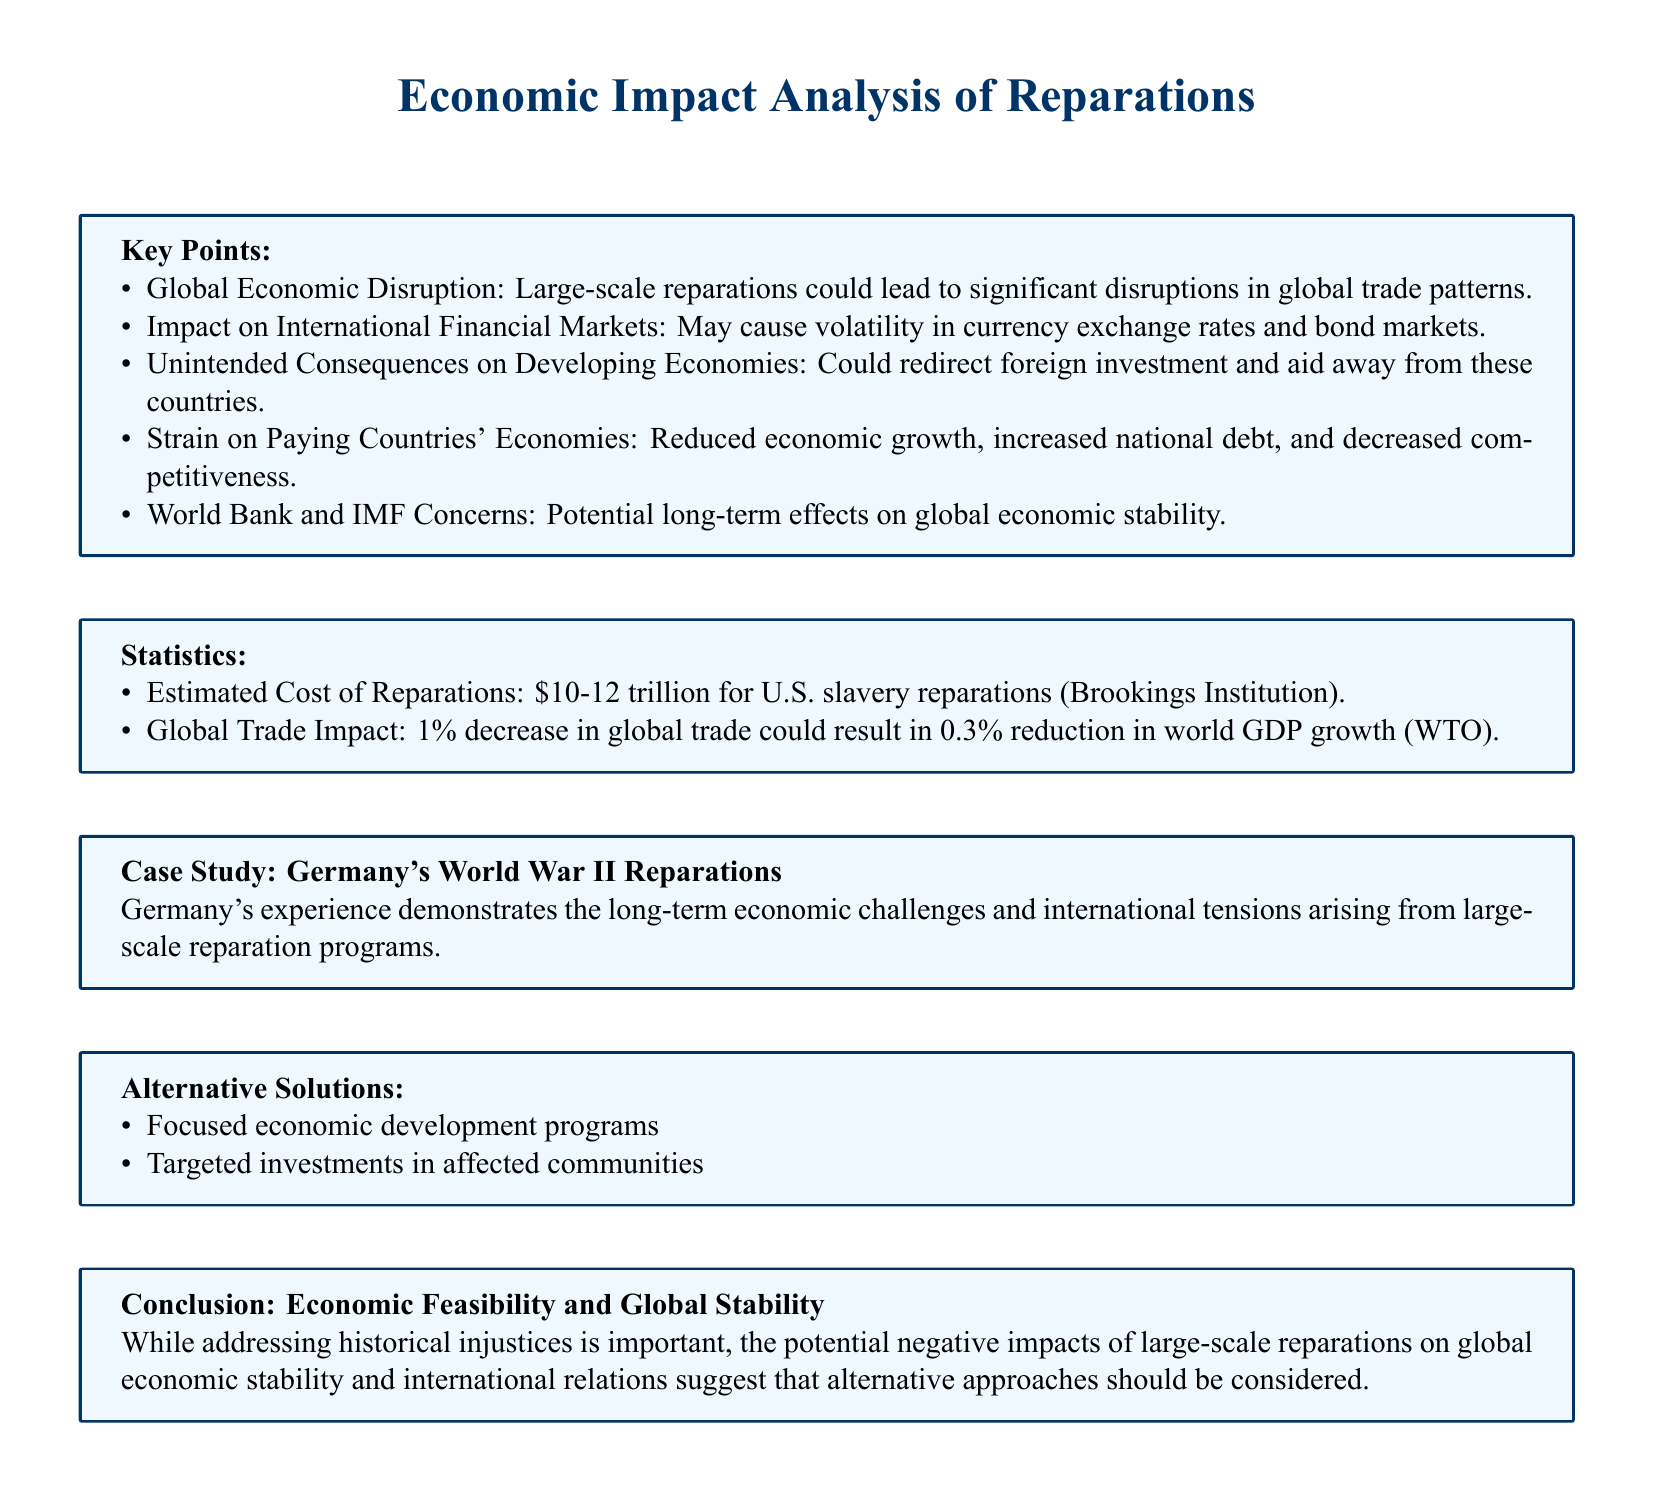What are the estimated costs of reparations? The document states an estimated cost for U.S. slavery reparations is between $10-12 trillion.
Answer: $10-12 trillion What is a potential consequence of large-scale reparations? It could lead to significant disruptions in global trade patterns, according to the key points.
Answer: Economic disruption What percentage decrease in global trade could impact world GDP growth? The document mentions a 1% decrease in global trade could result in a 0.3% reduction in world GDP growth.
Answer: 0.3% Which country’s case study is mentioned in the document? The case study discussed pertains to Germany's World War II reparations experience.
Answer: Germany What alternative solutions are suggested instead of reparations? The document lists focused economic development programs and targeted investments in affected communities as alternatives.
Answer: Focused economic development programs What concerns are mentioned regarding the World Bank and IMF? Potential long-term effects on global economic stability are highlighted as concerns.
Answer: Economic stability What could be the impact on foreign investment due to reparations? The document states that reparations could redirect foreign investment and aid away from developing economies.
Answer: Redirect foreign investment How do reparations affect the paying countries' economies? They may cause reduced economic growth, increased national debt, and decreased competitiveness.
Answer: Economic strain 